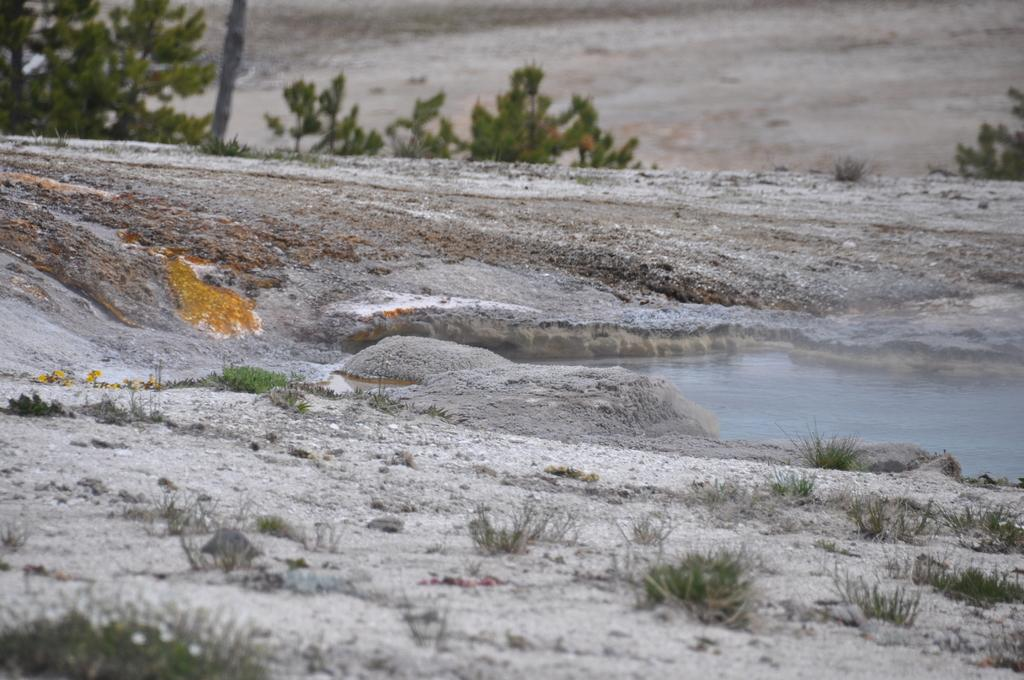What type of terrain is visible in the image? There is sand in the image. What else can be seen in the image besides sand? There is water, plants, and trees in the image. What type of lead is being used to solve arithmetic problems in the image? There is no lead or arithmetic problems present in the image. What type of vessel is being used to transport the water in the image? There is no vessel visible in the image; the water is directly in contact with the sand. 